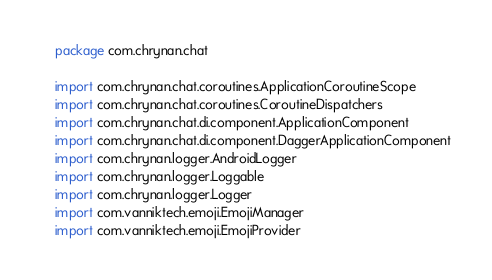Convert code to text. <code><loc_0><loc_0><loc_500><loc_500><_Kotlin_>package com.chrynan.chat

import com.chrynan.chat.coroutines.ApplicationCoroutineScope
import com.chrynan.chat.coroutines.CoroutineDispatchers
import com.chrynan.chat.di.component.ApplicationComponent
import com.chrynan.chat.di.component.DaggerApplicationComponent
import com.chrynan.logger.AndroidLogger
import com.chrynan.logger.Loggable
import com.chrynan.logger.Logger
import com.vanniktech.emoji.EmojiManager
import com.vanniktech.emoji.EmojiProvider</code> 